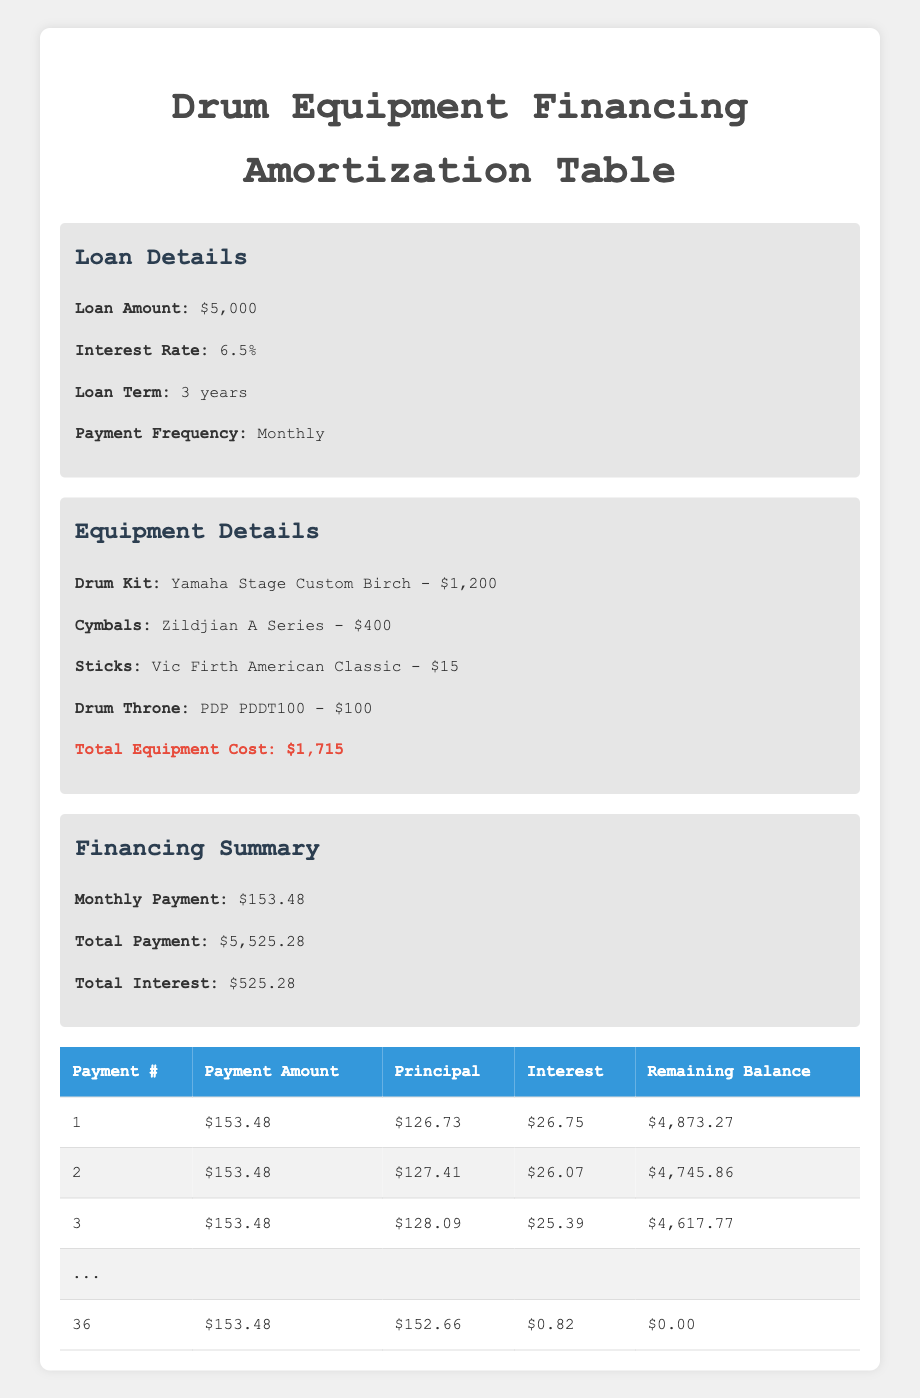What is the monthly payment amount for the loan? The table states that the monthly payment is explicitly shown in the "Financing Summary" section as $153.48.
Answer: 153.48 What is the total interest paid over the course of the loan? The total interest is also mentioned in the "Financing Summary" as $525.28.
Answer: 525.28 What is the price of the Yamaha drum kit? The "Equipment Details" section lists the price of the Yamaha Stage Custom Birch drum kit as $1,200.
Answer: 1200 In the first payment, how much of the payment goes toward the principal? Referring to the first row of the amortization table, the principal payment for Payment #1 is $126.73.
Answer: 126.73 How much is the remaining balance after the first payment? In the amortization table, for Payment #1, the remaining balance is shown as $4,873.27 after making the monthly payment.
Answer: 4873.27 What is the total payment amount over the entire loan term? The total payment is stated in the "Financing Summary" as $5,525.28, which includes all monthly payments combined.
Answer: 5525.28 Is the interest amount for the last payment lower than that of the first payment? The last payment (Payment #36) has an interest amount of $0.82, and the first payment has an interest amount of $26.75. Since $0.82 is less than $26.75, the statement is true.
Answer: Yes How much total principal is paid over the entire loan term? The total principal paid can be calculated by summing all principal payments across all payments. Since the total payment is $5,525.28 and total interest is $525.28, the total principal is $5,525.28 - $525.28 = $5,000.
Answer: 5000 What is the average monthly payment over the course of 36 months? Since the monthly payment is constant at $153.48 for all 36 months, the average monthly payment is simply $153.48 itself.
Answer: 153.48 